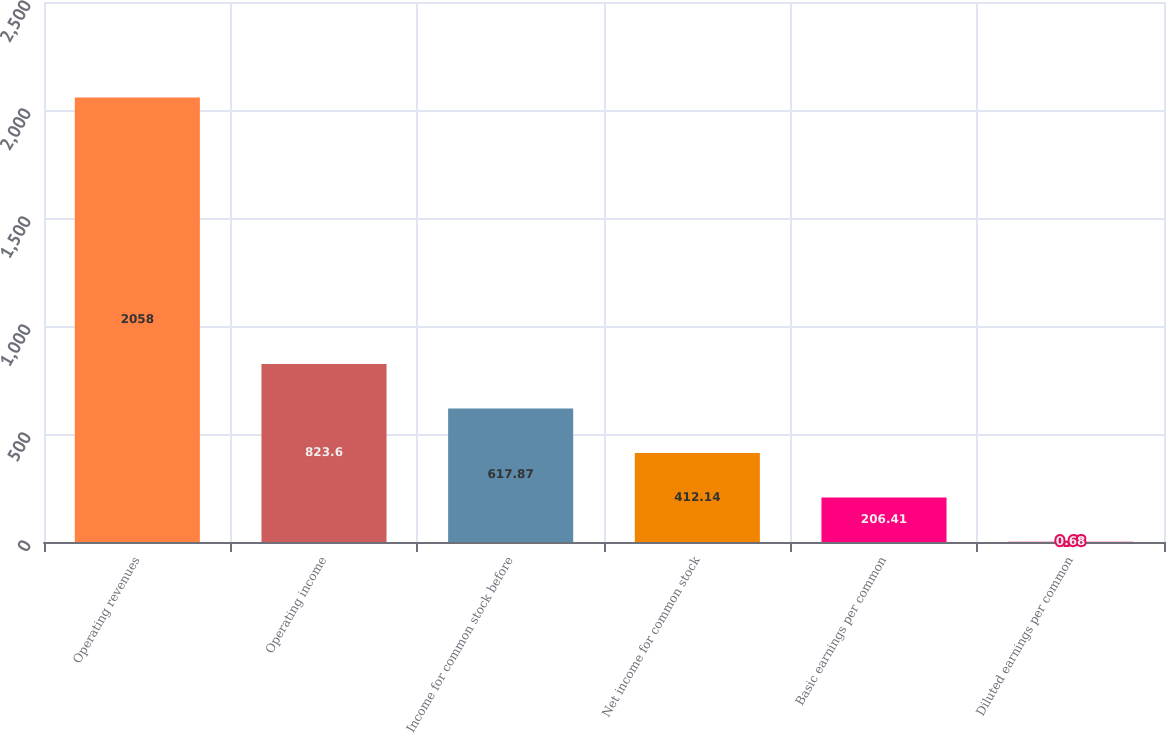<chart> <loc_0><loc_0><loc_500><loc_500><bar_chart><fcel>Operating revenues<fcel>Operating income<fcel>Income for common stock before<fcel>Net income for common stock<fcel>Basic earnings per common<fcel>Diluted earnings per common<nl><fcel>2058<fcel>823.6<fcel>617.87<fcel>412.14<fcel>206.41<fcel>0.68<nl></chart> 